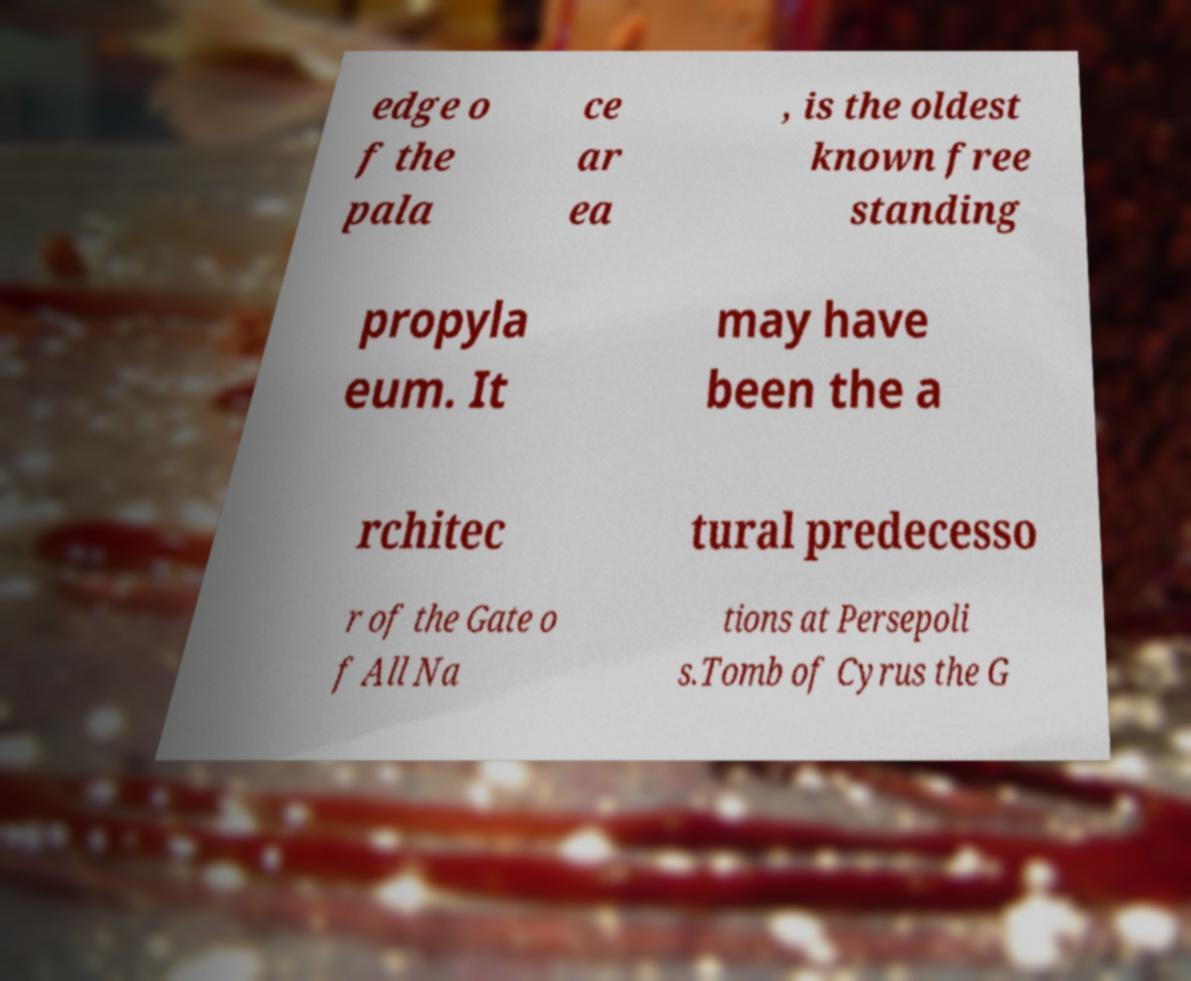Could you assist in decoding the text presented in this image and type it out clearly? edge o f the pala ce ar ea , is the oldest known free standing propyla eum. It may have been the a rchitec tural predecesso r of the Gate o f All Na tions at Persepoli s.Tomb of Cyrus the G 